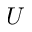<formula> <loc_0><loc_0><loc_500><loc_500>U</formula> 